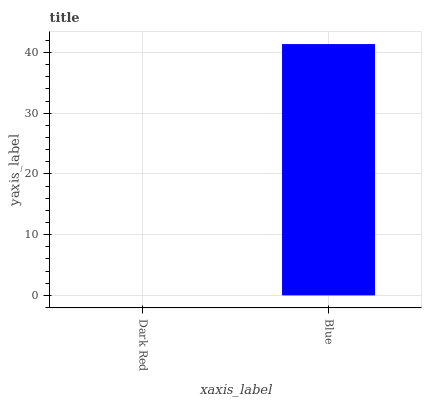Is Dark Red the minimum?
Answer yes or no. Yes. Is Blue the maximum?
Answer yes or no. Yes. Is Blue the minimum?
Answer yes or no. No. Is Blue greater than Dark Red?
Answer yes or no. Yes. Is Dark Red less than Blue?
Answer yes or no. Yes. Is Dark Red greater than Blue?
Answer yes or no. No. Is Blue less than Dark Red?
Answer yes or no. No. Is Blue the high median?
Answer yes or no. Yes. Is Dark Red the low median?
Answer yes or no. Yes. Is Dark Red the high median?
Answer yes or no. No. Is Blue the low median?
Answer yes or no. No. 